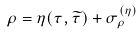<formula> <loc_0><loc_0><loc_500><loc_500>\rho = \eta ( \tau , \widetilde { \tau } ) + \sigma _ { \rho } ^ { ( \eta ) }</formula> 